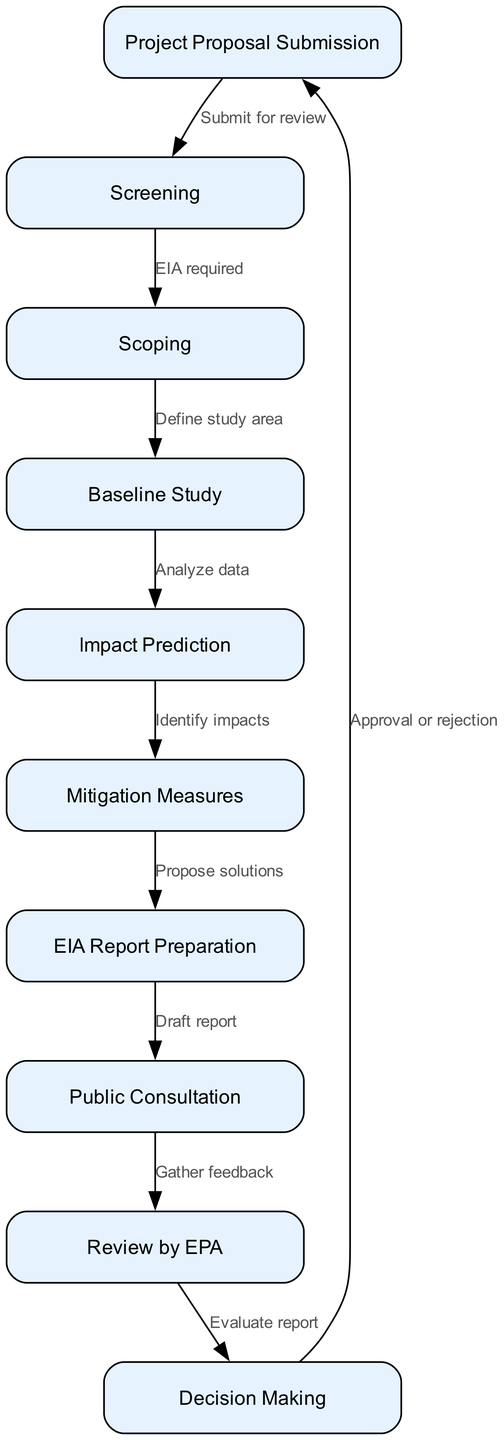What is the first step in the environmental impact assessment process? The first step is the "Project Proposal Submission," which occurs before any other processes. It is indicated as the root node of the flow diagram.
Answer: Project Proposal Submission How many nodes are in the diagram? The diagram includes a total of 10 nodes, each representing a different stage in the environmental impact assessment process.
Answer: 10 What is the label of the node that follows the "Mitigation Measures" node? The node that follows "Mitigation Measures" is "EIA Report Preparation." This flow is derived from the edge connecting node 6 to node 7.
Answer: EIA Report Preparation What is the direct relationship between "Scoping" and "Baseline Study"? "Scoping" leads directly to "Baseline Study," as indicated by the directed edge between node 3 and node 4.
Answer: Define study area What step occurs after "Public Consultation"? The step that follows "Public Consultation" is "Review by EPA," which is connected directly via an edge from node 8 to node 9.
Answer: Review by EPA Which node leads to the "Decision Making" stage? The node that leads to the "Decision Making" stage is "Review by EPA," as it is the preceding node, connected directly to node 10.
Answer: Review by EPA What action is required for the "Project Proposal Submission"? The required action for "Project Proposal Submission" is to "Submit for review," as stated in the edge linking node 1 to node 2.
Answer: Submit for review In the flowchart, how many steps are involved after the "Impact Prediction" node? There are two steps involved after the "Impact Prediction" node: "Mitigation Measures" and "EIA Report Preparation." This can be traced through the edges that go from node 5 to nodes 6 and 7.
Answer: Two steps What feedback action follows the "Draft report"? The feedback action that follows the "Draft report" is to "Gather feedback," as noted by the edge running from node 7 to node 8.
Answer: Gather feedback What is the final outcome represented in the flowchart? The flowchart represents the final outcome as "Approval or rejection," which can be seen at the end of the process as node 10 links back to the start.
Answer: Approval or rejection 